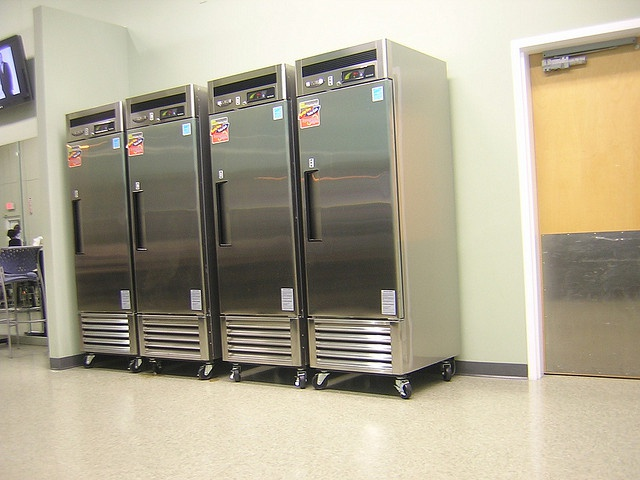Describe the objects in this image and their specific colors. I can see refrigerator in darkgray, gray, black, and tan tones, refrigerator in darkgray, gray, and black tones, refrigerator in darkgray, gray, and black tones, refrigerator in darkgray, gray, and black tones, and chair in darkgray, gray, and black tones in this image. 